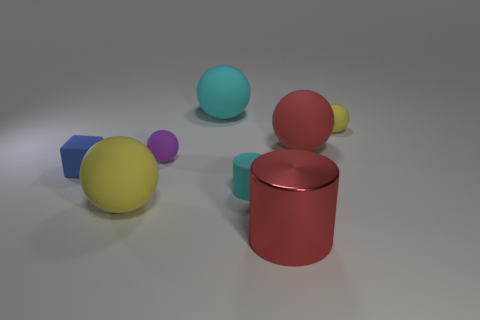Can you describe the spatial arrangement of the objects in the image? Certainly, the image displays a series of objects in varying colors and shapes on a flat surface. In the foreground, there is a shiny red cylinder standing upright. Directly behind it, a cyan sphere is visible. Further to the left, a matte yellow sphere is present, with two smaller spheres—one purple and one blue—beside it. Overall, the objects are spaced out, with no two objects touching each other. 